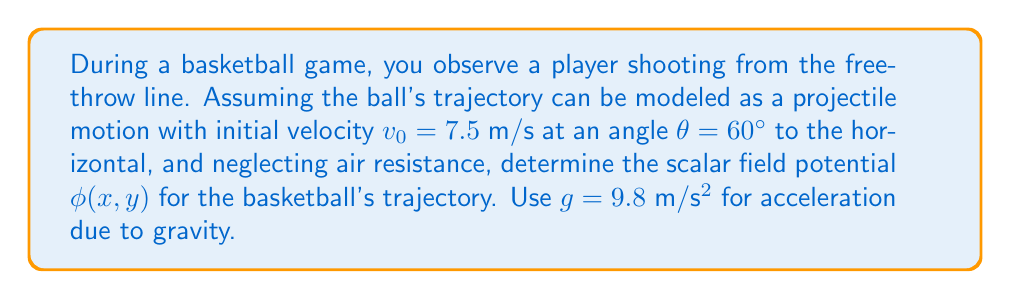Solve this math problem. To determine the scalar field potential for the basketball's trajectory, we'll follow these steps:

1) The trajectory of a projectile (like a basketball) in a uniform gravitational field can be described by a scalar field potential $\phi(x,y)$.

2) The general form of this potential is:

   $$\phi(x,y) = gy + \frac{1}{2}v_x^2 + \frac{1}{2}v_y^2$$

   where $g$ is the acceleration due to gravity, $y$ is the vertical position, and $v_x$ and $v_y$ are the x and y components of velocity.

3) We need to express $v_x$ and $v_y$ in terms of $x$ and $y$. For projectile motion:

   $$v_x = v_0 \cos(\theta)$$
   $$v_y = v_0 \sin(\theta) - gt$$

4) We can eliminate $t$ using the equation:

   $$x = v_0 \cos(\theta) t$$

   Solving for $t$:

   $$t = \frac{x}{v_0 \cos(\theta)}$$

5) Substituting this into the equation for $v_y$:

   $$v_y = v_0 \sin(\theta) - g\frac{x}{v_0 \cos(\theta)}$$

6) Now we can write our potential function:

   $$\phi(x,y) = gy + \frac{1}{2}(v_0 \cos(\theta))^2 + \frac{1}{2}(v_0 \sin(\theta) - g\frac{x}{v_0 \cos(\theta)})^2$$

7) Substituting the given values:

   $$\phi(x,y) = 9.8y + \frac{1}{2}(7.5 \cos(60°))^2 + \frac{1}{2}(7.5 \sin(60°) - 9.8\frac{x}{7.5 \cos(60°)})^2$$

8) Simplifying:

   $$\phi(x,y) = 9.8y + \frac{1}{2}(3.75)^2 + \frac{1}{2}(6.495 - 2.613x)^2$$

   $$\phi(x,y) = 9.8y + 7.03125 + \frac{1}{2}(42.1851 - 33.95814x + 6.82797x^2)$$

9) Final simplification:

   $$\phi(x,y) = 9.8y + 28.123 - 16.979x + 3.414x^2$$

This is the scalar field potential for the basketball's trajectory.
Answer: $$\phi(x,y) = 9.8y + 28.123 - 16.979x + 3.414x^2$$ 